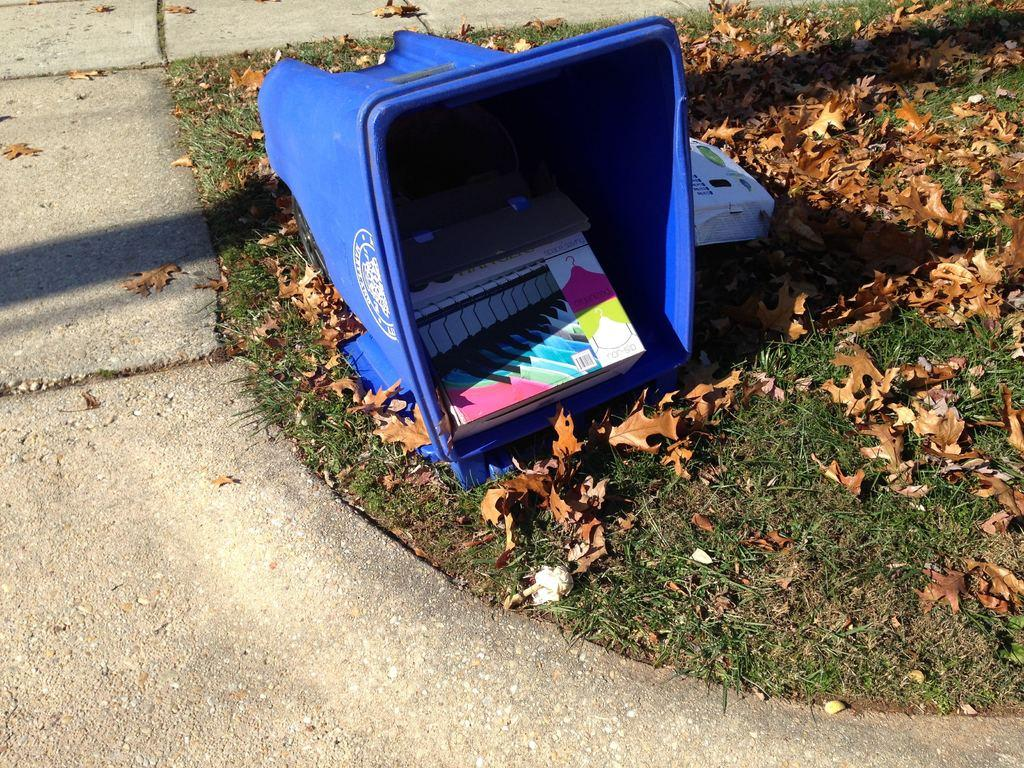What is inside the dustbin in the image? There is an item in a dustbin in the image. Where is the dustbin located? The dustbin is on the grass. What type of vegetation can be seen in the image? There are leaves in the image. What else can be seen in the image besides the dustbin and leaves? There is an object in the image. What type of man-made structure is visible in the image? There is a road visible in the image. What type of line can be seen in the image? There is no line present in the image. What error can be corrected in the image? There is no error present in the image. 